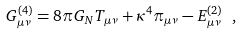Convert formula to latex. <formula><loc_0><loc_0><loc_500><loc_500>G ^ { ( 4 ) } _ { \mu \nu } = 8 \pi G _ { N } T _ { \mu \nu } + \kappa ^ { 4 } \pi _ { \mu \nu } - E ^ { ( 2 ) } _ { \mu \nu } \ ,</formula> 